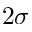Convert formula to latex. <formula><loc_0><loc_0><loc_500><loc_500>2 \sigma</formula> 